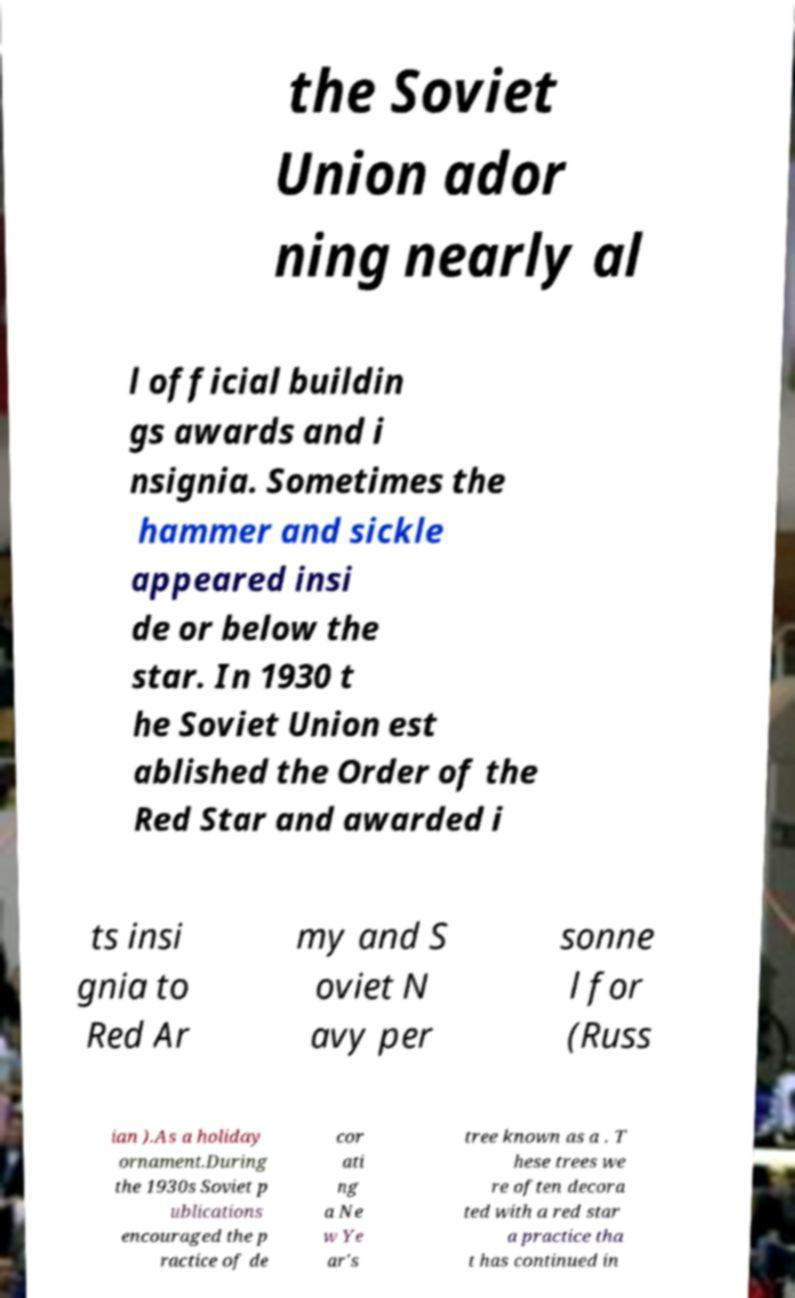Can you read and provide the text displayed in the image?This photo seems to have some interesting text. Can you extract and type it out for me? the Soviet Union ador ning nearly al l official buildin gs awards and i nsignia. Sometimes the hammer and sickle appeared insi de or below the star. In 1930 t he Soviet Union est ablished the Order of the Red Star and awarded i ts insi gnia to Red Ar my and S oviet N avy per sonne l for (Russ ian ).As a holiday ornament.During the 1930s Soviet p ublications encouraged the p ractice of de cor ati ng a Ne w Ye ar's tree known as a . T hese trees we re often decora ted with a red star a practice tha t has continued in 